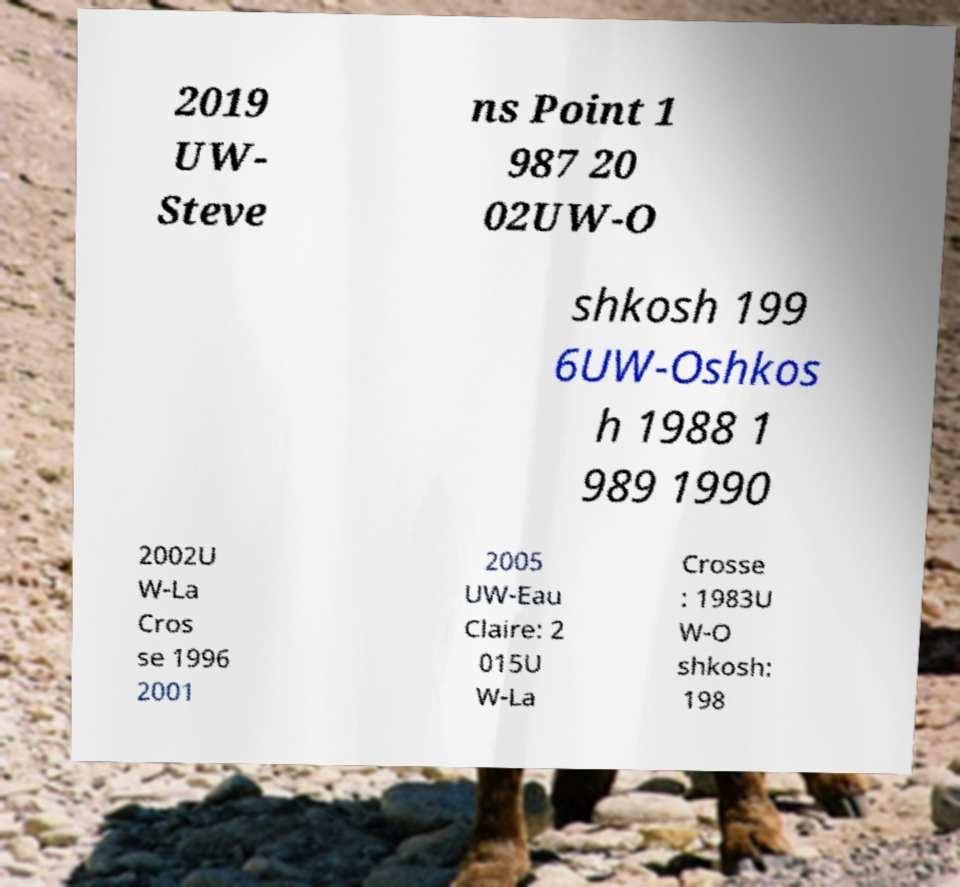Please read and relay the text visible in this image. What does it say? 2019 UW- Steve ns Point 1 987 20 02UW-O shkosh 199 6UW-Oshkos h 1988 1 989 1990 2002U W-La Cros se 1996 2001 2005 UW-Eau Claire: 2 015U W-La Crosse : 1983U W-O shkosh: 198 